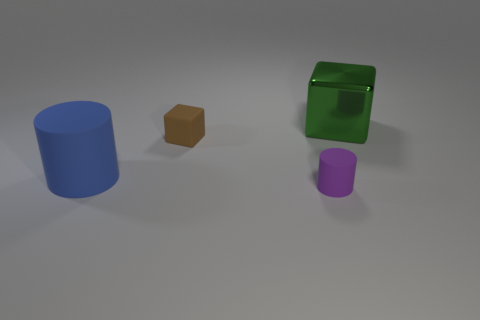What color is the big cylinder that is the same material as the tiny purple object?
Offer a very short reply. Blue. Are there any green shiny cubes that have the same size as the blue cylinder?
Provide a succinct answer. Yes. There is a blue rubber object that is the same size as the green metal cube; what is its shape?
Your response must be concise. Cylinder. Are there any brown objects that have the same shape as the tiny purple matte thing?
Give a very brief answer. No. Do the small purple cylinder and the big thing in front of the green metal cube have the same material?
Your answer should be very brief. Yes. Is there another rubber block of the same color as the tiny block?
Provide a short and direct response. No. What number of other objects are there of the same material as the small cube?
Make the answer very short. 2. Is the color of the big rubber object the same as the block left of the large metal block?
Provide a short and direct response. No. Are there more green cubes that are on the left side of the large blue thing than small blocks?
Give a very brief answer. No. There is a rubber object right of the small object that is behind the big blue thing; what number of brown rubber objects are behind it?
Your answer should be very brief. 1. 